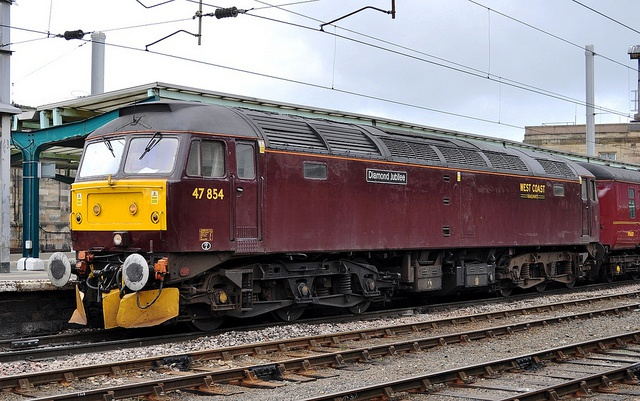Describe the objects in this image and their specific colors. I can see a train in black, maroon, gray, and darkgray tones in this image. 